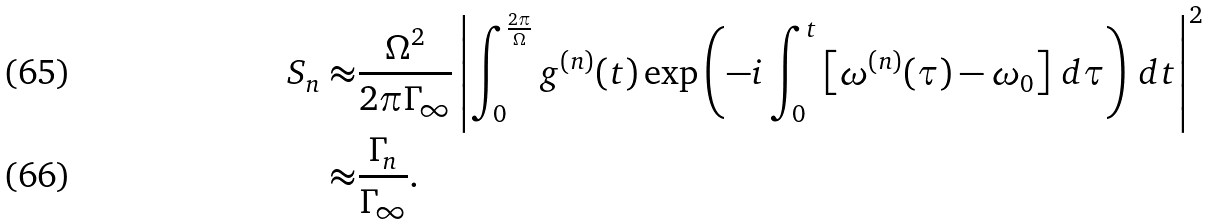<formula> <loc_0><loc_0><loc_500><loc_500>S _ { n } \approx & \frac { \Omega ^ { 2 } } { 2 \pi \Gamma _ { \infty } } \left | \int _ { 0 } ^ { \frac { 2 \pi } { \Omega } } g ^ { ( n ) } ( t ) \exp \left ( - i \int _ { 0 } ^ { t } \left [ \omega ^ { ( n ) } ( \tau ) - \omega _ { 0 } \right ] \, d \tau \right ) \, d t \right | ^ { 2 } \\ \approx & \frac { \Gamma _ { n } } { \Gamma _ { \infty } } .</formula> 